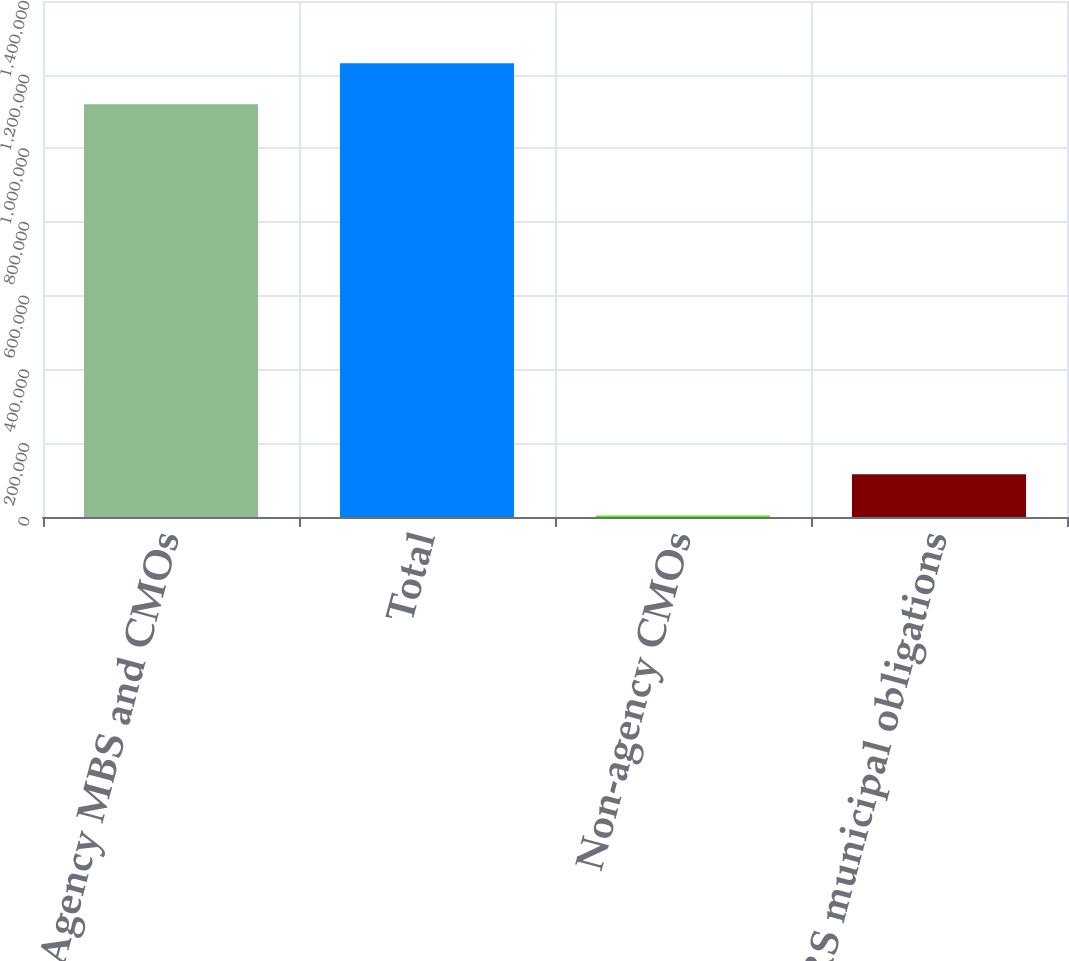Convert chart to OTSL. <chart><loc_0><loc_0><loc_500><loc_500><bar_chart><fcel>Agency MBS and CMOs<fcel>Total<fcel>Non-agency CMOs<fcel>ARS municipal obligations<nl><fcel>1.11972e+06<fcel>1.23126e+06<fcel>4256<fcel>115802<nl></chart> 